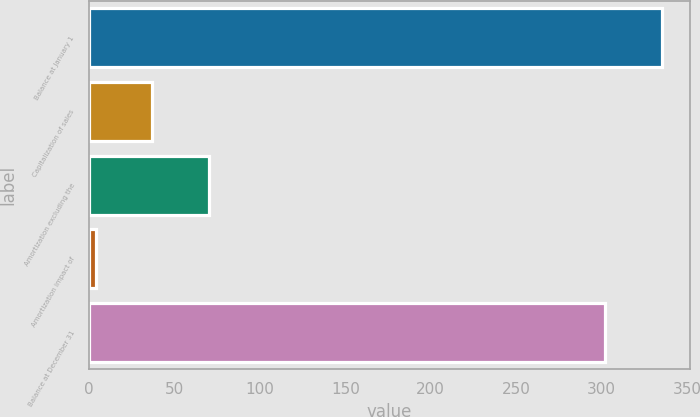Convert chart. <chart><loc_0><loc_0><loc_500><loc_500><bar_chart><fcel>Balance at January 1<fcel>Capitalization of sales<fcel>Amortization excluding the<fcel>Amortization impact of<fcel>Balance at December 31<nl><fcel>335.1<fcel>37.1<fcel>70.2<fcel>4<fcel>302<nl></chart> 